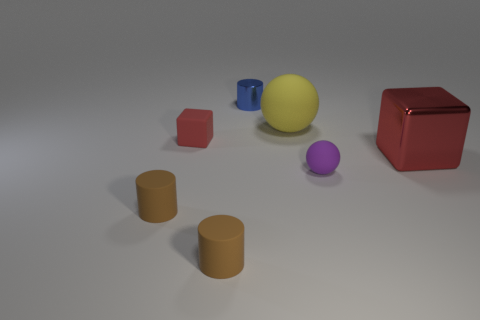Subtract all brown cylinders. How many cylinders are left? 1 Subtract all blue cylinders. How many cylinders are left? 2 Subtract all spheres. How many objects are left? 5 Add 1 large brown rubber blocks. How many objects exist? 8 Subtract 1 cylinders. How many cylinders are left? 2 Subtract all gray balls. How many brown cylinders are left? 2 Subtract all yellow rubber things. Subtract all yellow metal balls. How many objects are left? 6 Add 4 rubber blocks. How many rubber blocks are left? 5 Add 5 blue cylinders. How many blue cylinders exist? 6 Subtract 0 yellow cylinders. How many objects are left? 7 